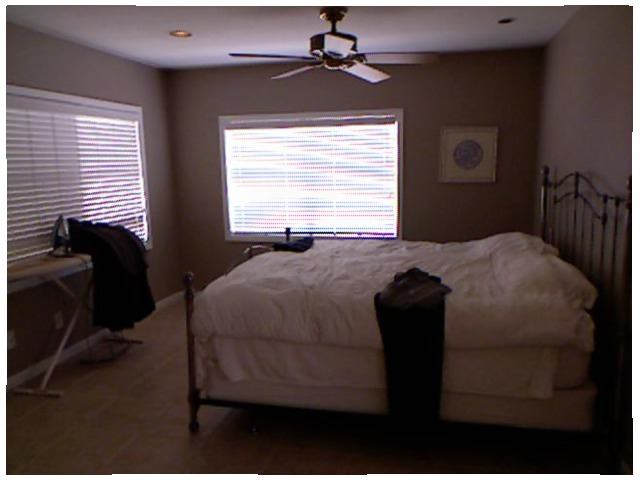<image>
Is there a fan on the ceiling? Yes. Looking at the image, I can see the fan is positioned on top of the ceiling, with the ceiling providing support. Where is the fan in relation to the bed? Is it on the bed? No. The fan is not positioned on the bed. They may be near each other, but the fan is not supported by or resting on top of the bed. Is there a fan under the bed? No. The fan is not positioned under the bed. The vertical relationship between these objects is different. Where is the fan in relation to the bed? Is it next to the bed? No. The fan is not positioned next to the bed. They are located in different areas of the scene. 